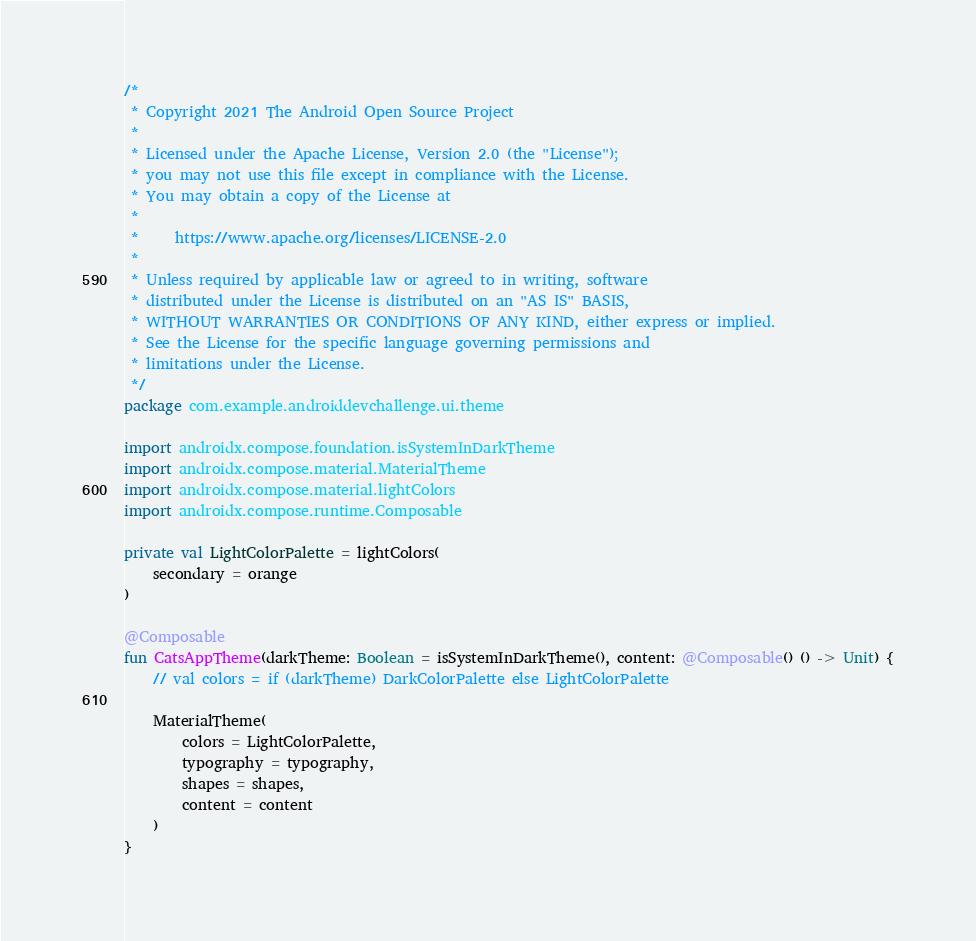<code> <loc_0><loc_0><loc_500><loc_500><_Kotlin_>/*
 * Copyright 2021 The Android Open Source Project
 *
 * Licensed under the Apache License, Version 2.0 (the "License");
 * you may not use this file except in compliance with the License.
 * You may obtain a copy of the License at
 *
 *     https://www.apache.org/licenses/LICENSE-2.0
 *
 * Unless required by applicable law or agreed to in writing, software
 * distributed under the License is distributed on an "AS IS" BASIS,
 * WITHOUT WARRANTIES OR CONDITIONS OF ANY KIND, either express or implied.
 * See the License for the specific language governing permissions and
 * limitations under the License.
 */
package com.example.androiddevchallenge.ui.theme

import androidx.compose.foundation.isSystemInDarkTheme
import androidx.compose.material.MaterialTheme
import androidx.compose.material.lightColors
import androidx.compose.runtime.Composable

private val LightColorPalette = lightColors(
    secondary = orange
)

@Composable
fun CatsAppTheme(darkTheme: Boolean = isSystemInDarkTheme(), content: @Composable() () -> Unit) {
    // val colors = if (darkTheme) DarkColorPalette else LightColorPalette

    MaterialTheme(
        colors = LightColorPalette,
        typography = typography,
        shapes = shapes,
        content = content
    )
}
</code> 